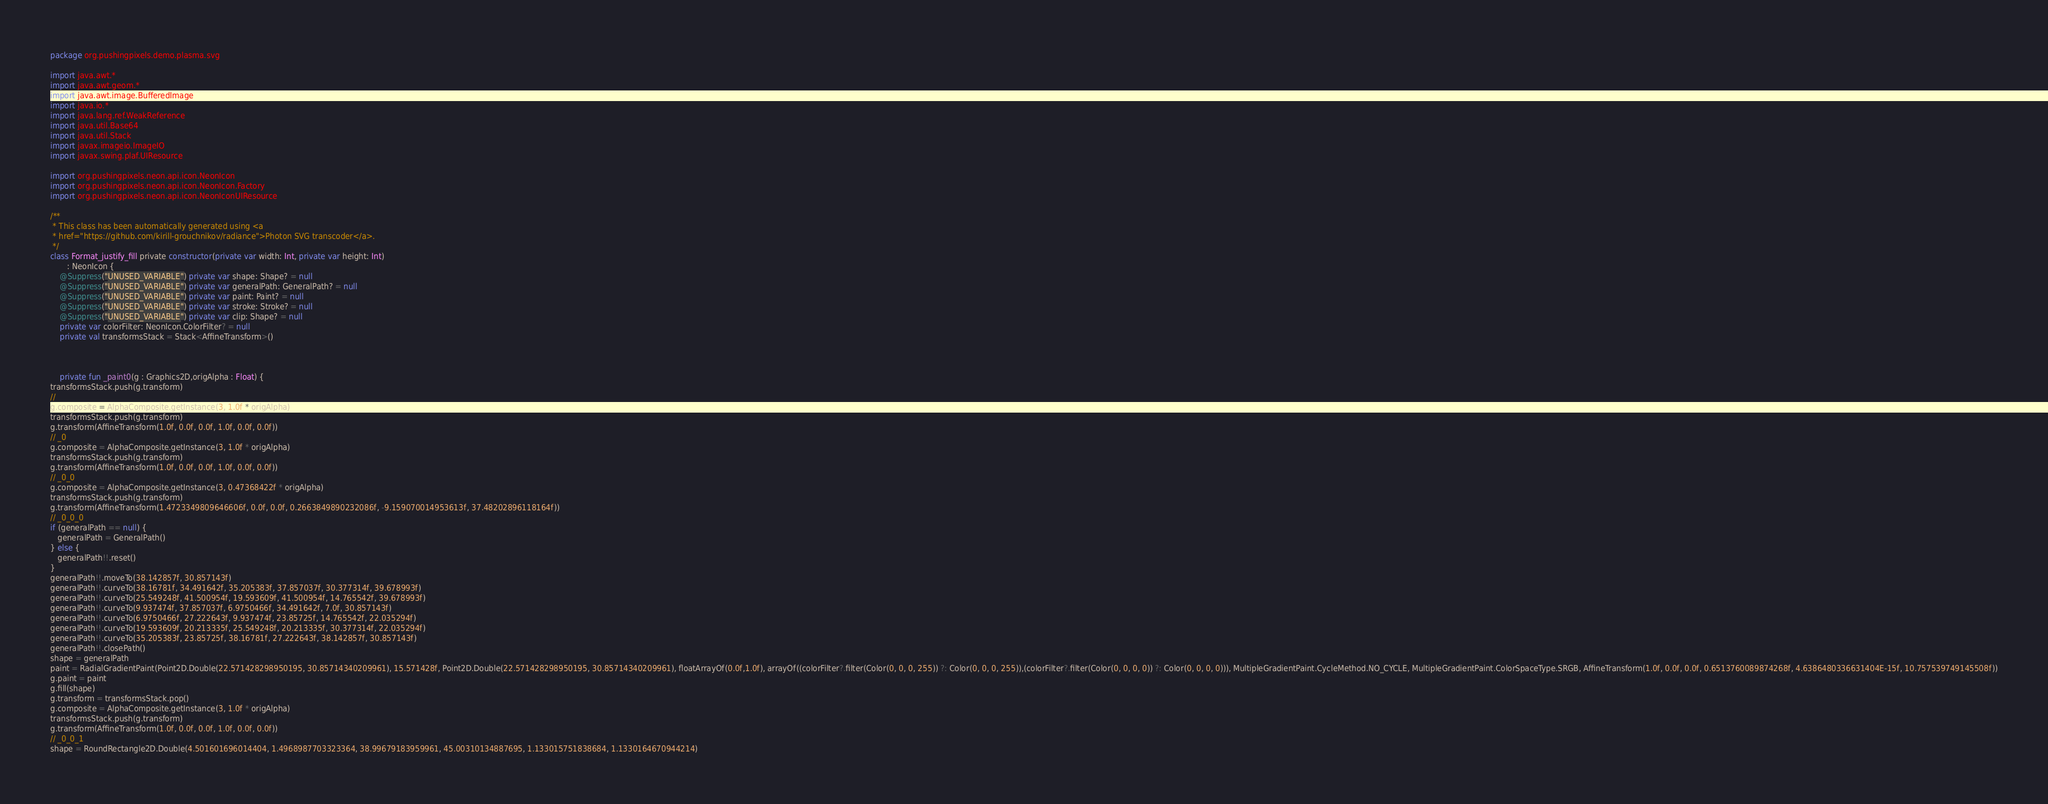Convert code to text. <code><loc_0><loc_0><loc_500><loc_500><_Kotlin_>package org.pushingpixels.demo.plasma.svg

import java.awt.*
import java.awt.geom.*
import java.awt.image.BufferedImage
import java.io.*
import java.lang.ref.WeakReference
import java.util.Base64
import java.util.Stack
import javax.imageio.ImageIO
import javax.swing.plaf.UIResource

import org.pushingpixels.neon.api.icon.NeonIcon
import org.pushingpixels.neon.api.icon.NeonIcon.Factory
import org.pushingpixels.neon.api.icon.NeonIconUIResource

/**
 * This class has been automatically generated using <a
 * href="https://github.com/kirill-grouchnikov/radiance">Photon SVG transcoder</a>.
 */
class Format_justify_fill private constructor(private var width: Int, private var height: Int)
       : NeonIcon {
    @Suppress("UNUSED_VARIABLE") private var shape: Shape? = null
    @Suppress("UNUSED_VARIABLE") private var generalPath: GeneralPath? = null
    @Suppress("UNUSED_VARIABLE") private var paint: Paint? = null
    @Suppress("UNUSED_VARIABLE") private var stroke: Stroke? = null
    @Suppress("UNUSED_VARIABLE") private var clip: Shape? = null
    private var colorFilter: NeonIcon.ColorFilter? = null
    private val transformsStack = Stack<AffineTransform>()

    

	private fun _paint0(g : Graphics2D,origAlpha : Float) {
transformsStack.push(g.transform)
// 
g.composite = AlphaComposite.getInstance(3, 1.0f * origAlpha)
transformsStack.push(g.transform)
g.transform(AffineTransform(1.0f, 0.0f, 0.0f, 1.0f, 0.0f, 0.0f))
// _0
g.composite = AlphaComposite.getInstance(3, 1.0f * origAlpha)
transformsStack.push(g.transform)
g.transform(AffineTransform(1.0f, 0.0f, 0.0f, 1.0f, 0.0f, 0.0f))
// _0_0
g.composite = AlphaComposite.getInstance(3, 0.47368422f * origAlpha)
transformsStack.push(g.transform)
g.transform(AffineTransform(1.4723349809646606f, 0.0f, 0.0f, 0.2663849890232086f, -9.159070014953613f, 37.48202896118164f))
// _0_0_0
if (generalPath == null) {
   generalPath = GeneralPath()
} else {
   generalPath!!.reset()
}
generalPath!!.moveTo(38.142857f, 30.857143f)
generalPath!!.curveTo(38.16781f, 34.491642f, 35.205383f, 37.857037f, 30.377314f, 39.678993f)
generalPath!!.curveTo(25.549248f, 41.500954f, 19.593609f, 41.500954f, 14.765542f, 39.678993f)
generalPath!!.curveTo(9.937474f, 37.857037f, 6.9750466f, 34.491642f, 7.0f, 30.857143f)
generalPath!!.curveTo(6.9750466f, 27.222643f, 9.937474f, 23.85725f, 14.765542f, 22.035294f)
generalPath!!.curveTo(19.593609f, 20.213335f, 25.549248f, 20.213335f, 30.377314f, 22.035294f)
generalPath!!.curveTo(35.205383f, 23.85725f, 38.16781f, 27.222643f, 38.142857f, 30.857143f)
generalPath!!.closePath()
shape = generalPath
paint = RadialGradientPaint(Point2D.Double(22.571428298950195, 30.85714340209961), 15.571428f, Point2D.Double(22.571428298950195, 30.85714340209961), floatArrayOf(0.0f,1.0f), arrayOf((colorFilter?.filter(Color(0, 0, 0, 255)) ?: Color(0, 0, 0, 255)),(colorFilter?.filter(Color(0, 0, 0, 0)) ?: Color(0, 0, 0, 0))), MultipleGradientPaint.CycleMethod.NO_CYCLE, MultipleGradientPaint.ColorSpaceType.SRGB, AffineTransform(1.0f, 0.0f, 0.0f, 0.6513760089874268f, 4.6386480336631404E-15f, 10.757539749145508f))
g.paint = paint
g.fill(shape)
g.transform = transformsStack.pop()
g.composite = AlphaComposite.getInstance(3, 1.0f * origAlpha)
transformsStack.push(g.transform)
g.transform(AffineTransform(1.0f, 0.0f, 0.0f, 1.0f, 0.0f, 0.0f))
// _0_0_1
shape = RoundRectangle2D.Double(4.501601696014404, 1.4968987703323364, 38.99679183959961, 45.00310134887695, 1.133015751838684, 1.1330164670944214)</code> 